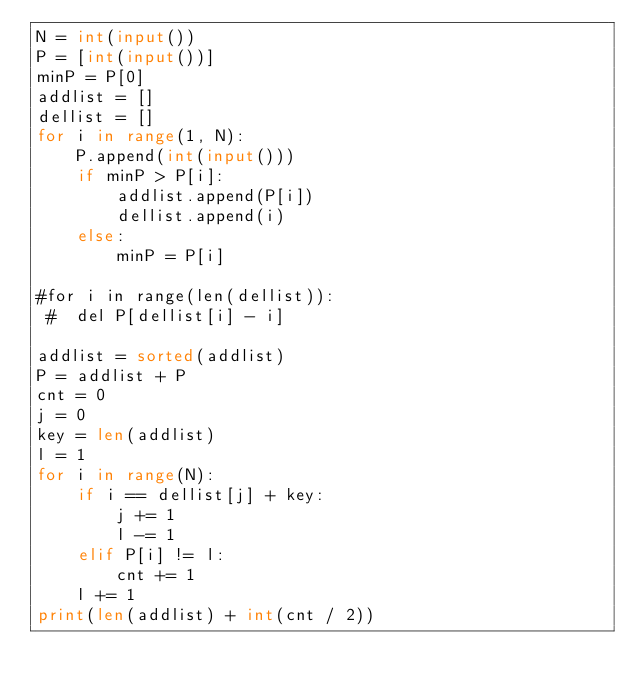<code> <loc_0><loc_0><loc_500><loc_500><_Python_>N = int(input())
P = [int(input())]
minP = P[0]
addlist = []
dellist = []
for i in range(1, N):
    P.append(int(input()))
    if minP > P[i]:
        addlist.append(P[i])
        dellist.append(i)
    else:
        minP = P[i]

#for i in range(len(dellist)):
 #  del P[dellist[i] - i]
    
addlist = sorted(addlist)
P = addlist + P
cnt = 0
j = 0
key = len(addlist)
l = 1
for i in range(N):
    if i == dellist[j] + key:
        j += 1
        l -= 1
    elif P[i] != l:
        cnt += 1
    l += 1
print(len(addlist) + int(cnt / 2))
</code> 